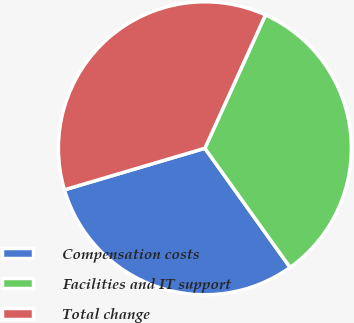<chart> <loc_0><loc_0><loc_500><loc_500><pie_chart><fcel>Compensation costs<fcel>Facilities and IT support<fcel>Total change<nl><fcel>30.3%<fcel>33.33%<fcel>36.36%<nl></chart> 